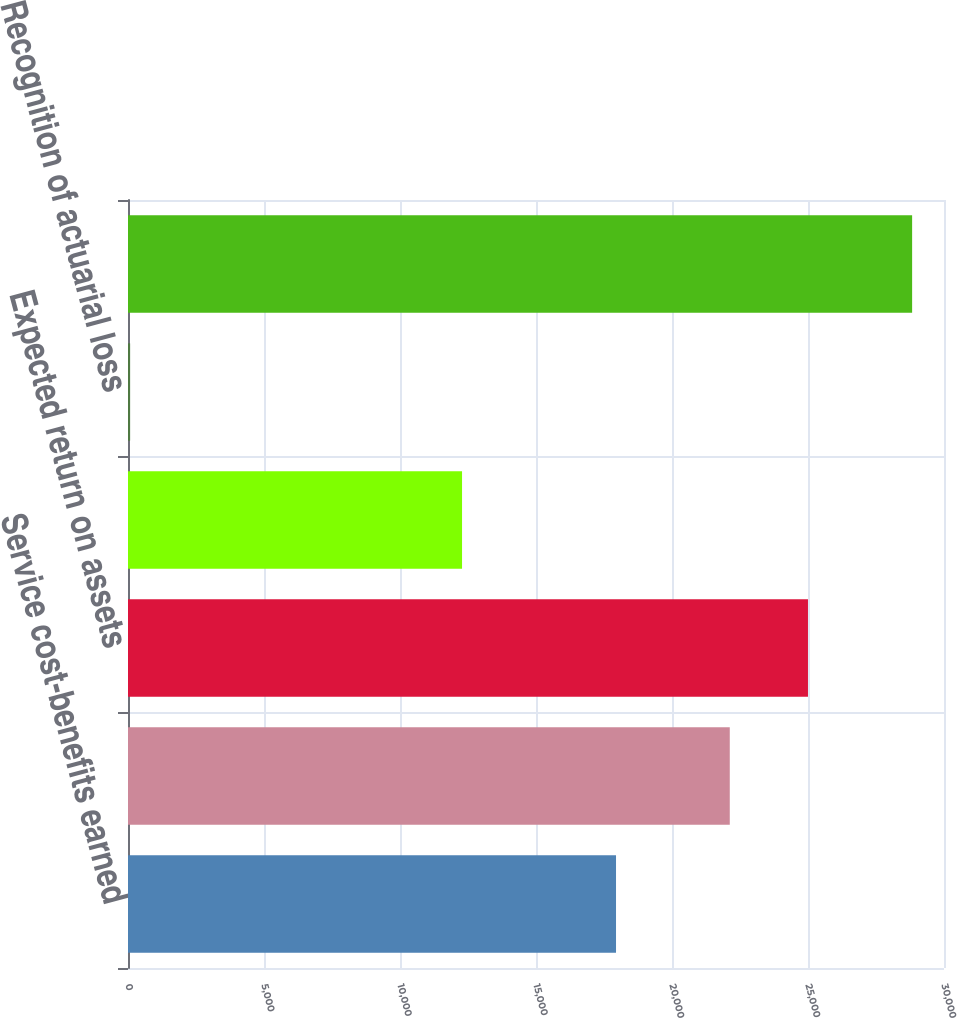Convert chart to OTSL. <chart><loc_0><loc_0><loc_500><loc_500><bar_chart><fcel>Service cost-benefits earned<fcel>Interest cost on projected<fcel>Expected return on assets<fcel>Net amortization<fcel>Recognition of actuarial loss<fcel>Net periodic pension cost<nl><fcel>17942<fcel>22124<fcel>24999<fcel>12281<fcel>78<fcel>28828<nl></chart> 